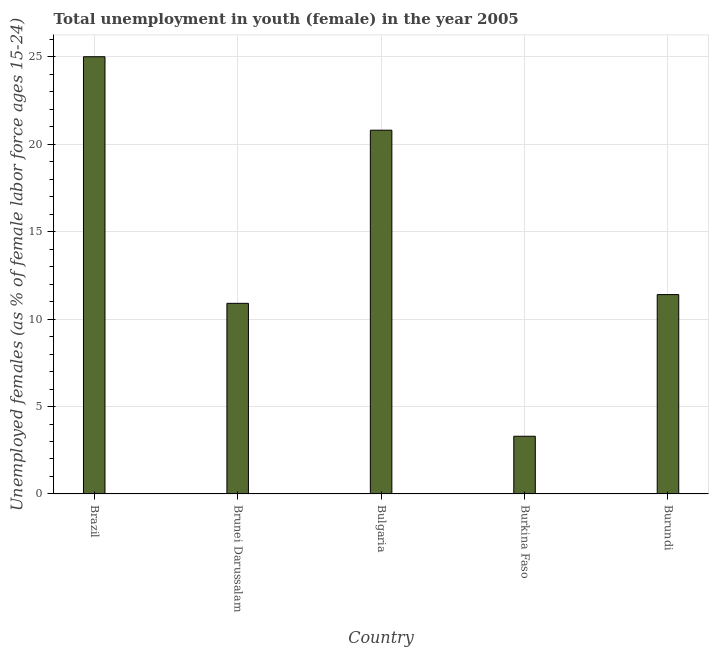Does the graph contain any zero values?
Your response must be concise. No. What is the title of the graph?
Ensure brevity in your answer.  Total unemployment in youth (female) in the year 2005. What is the label or title of the Y-axis?
Provide a succinct answer. Unemployed females (as % of female labor force ages 15-24). What is the unemployed female youth population in Burundi?
Provide a succinct answer. 11.4. Across all countries, what is the minimum unemployed female youth population?
Make the answer very short. 3.3. In which country was the unemployed female youth population maximum?
Ensure brevity in your answer.  Brazil. In which country was the unemployed female youth population minimum?
Give a very brief answer. Burkina Faso. What is the sum of the unemployed female youth population?
Keep it short and to the point. 71.4. What is the difference between the unemployed female youth population in Brazil and Bulgaria?
Your answer should be compact. 4.2. What is the average unemployed female youth population per country?
Give a very brief answer. 14.28. What is the median unemployed female youth population?
Ensure brevity in your answer.  11.4. What is the ratio of the unemployed female youth population in Bulgaria to that in Burkina Faso?
Your answer should be compact. 6.3. What is the difference between the highest and the lowest unemployed female youth population?
Your response must be concise. 21.7. Are all the bars in the graph horizontal?
Ensure brevity in your answer.  No. How many countries are there in the graph?
Make the answer very short. 5. What is the Unemployed females (as % of female labor force ages 15-24) in Brazil?
Offer a terse response. 25. What is the Unemployed females (as % of female labor force ages 15-24) in Brunei Darussalam?
Give a very brief answer. 10.9. What is the Unemployed females (as % of female labor force ages 15-24) of Bulgaria?
Provide a succinct answer. 20.8. What is the Unemployed females (as % of female labor force ages 15-24) of Burkina Faso?
Your answer should be compact. 3.3. What is the Unemployed females (as % of female labor force ages 15-24) of Burundi?
Make the answer very short. 11.4. What is the difference between the Unemployed females (as % of female labor force ages 15-24) in Brazil and Brunei Darussalam?
Offer a terse response. 14.1. What is the difference between the Unemployed females (as % of female labor force ages 15-24) in Brazil and Bulgaria?
Your response must be concise. 4.2. What is the difference between the Unemployed females (as % of female labor force ages 15-24) in Brazil and Burkina Faso?
Keep it short and to the point. 21.7. What is the difference between the Unemployed females (as % of female labor force ages 15-24) in Bulgaria and Burundi?
Make the answer very short. 9.4. What is the difference between the Unemployed females (as % of female labor force ages 15-24) in Burkina Faso and Burundi?
Give a very brief answer. -8.1. What is the ratio of the Unemployed females (as % of female labor force ages 15-24) in Brazil to that in Brunei Darussalam?
Offer a terse response. 2.29. What is the ratio of the Unemployed females (as % of female labor force ages 15-24) in Brazil to that in Bulgaria?
Ensure brevity in your answer.  1.2. What is the ratio of the Unemployed females (as % of female labor force ages 15-24) in Brazil to that in Burkina Faso?
Keep it short and to the point. 7.58. What is the ratio of the Unemployed females (as % of female labor force ages 15-24) in Brazil to that in Burundi?
Provide a succinct answer. 2.19. What is the ratio of the Unemployed females (as % of female labor force ages 15-24) in Brunei Darussalam to that in Bulgaria?
Offer a very short reply. 0.52. What is the ratio of the Unemployed females (as % of female labor force ages 15-24) in Brunei Darussalam to that in Burkina Faso?
Provide a short and direct response. 3.3. What is the ratio of the Unemployed females (as % of female labor force ages 15-24) in Brunei Darussalam to that in Burundi?
Give a very brief answer. 0.96. What is the ratio of the Unemployed females (as % of female labor force ages 15-24) in Bulgaria to that in Burkina Faso?
Keep it short and to the point. 6.3. What is the ratio of the Unemployed females (as % of female labor force ages 15-24) in Bulgaria to that in Burundi?
Make the answer very short. 1.82. What is the ratio of the Unemployed females (as % of female labor force ages 15-24) in Burkina Faso to that in Burundi?
Make the answer very short. 0.29. 